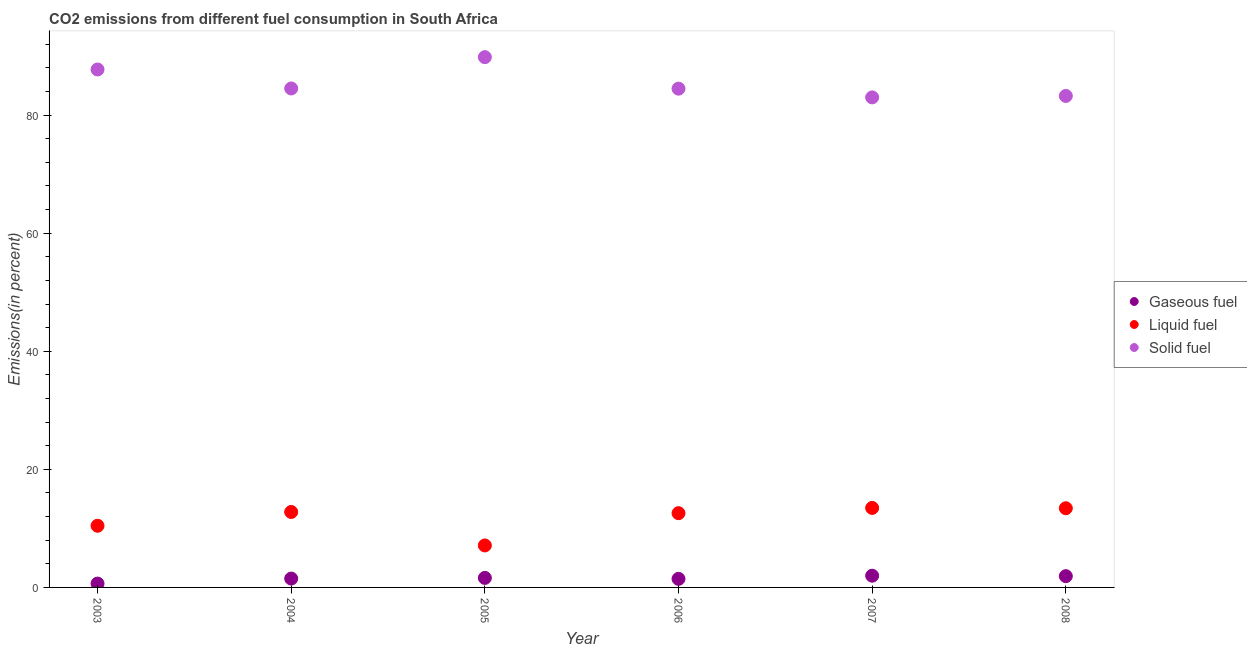Is the number of dotlines equal to the number of legend labels?
Your answer should be very brief. Yes. What is the percentage of solid fuel emission in 2007?
Your answer should be very brief. 83. Across all years, what is the maximum percentage of gaseous fuel emission?
Provide a short and direct response. 1.99. Across all years, what is the minimum percentage of solid fuel emission?
Make the answer very short. 83. In which year was the percentage of solid fuel emission maximum?
Provide a short and direct response. 2005. What is the total percentage of solid fuel emission in the graph?
Ensure brevity in your answer.  512.79. What is the difference between the percentage of solid fuel emission in 2005 and that in 2008?
Your answer should be very brief. 6.57. What is the difference between the percentage of gaseous fuel emission in 2003 and the percentage of liquid fuel emission in 2004?
Keep it short and to the point. -12.13. What is the average percentage of solid fuel emission per year?
Offer a terse response. 85.46. In the year 2008, what is the difference between the percentage of gaseous fuel emission and percentage of liquid fuel emission?
Provide a succinct answer. -11.5. What is the ratio of the percentage of gaseous fuel emission in 2003 to that in 2008?
Offer a terse response. 0.34. What is the difference between the highest and the second highest percentage of solid fuel emission?
Ensure brevity in your answer.  2.09. What is the difference between the highest and the lowest percentage of solid fuel emission?
Your response must be concise. 6.81. In how many years, is the percentage of gaseous fuel emission greater than the average percentage of gaseous fuel emission taken over all years?
Your answer should be compact. 3. Does the percentage of liquid fuel emission monotonically increase over the years?
Your answer should be compact. No. How many dotlines are there?
Give a very brief answer. 3. Are the values on the major ticks of Y-axis written in scientific E-notation?
Your response must be concise. No. Where does the legend appear in the graph?
Keep it short and to the point. Center right. How many legend labels are there?
Your response must be concise. 3. How are the legend labels stacked?
Your answer should be compact. Vertical. What is the title of the graph?
Provide a succinct answer. CO2 emissions from different fuel consumption in South Africa. Does "Nuclear sources" appear as one of the legend labels in the graph?
Keep it short and to the point. No. What is the label or title of the Y-axis?
Your answer should be very brief. Emissions(in percent). What is the Emissions(in percent) of Gaseous fuel in 2003?
Keep it short and to the point. 0.65. What is the Emissions(in percent) in Liquid fuel in 2003?
Offer a terse response. 10.45. What is the Emissions(in percent) in Solid fuel in 2003?
Your response must be concise. 87.73. What is the Emissions(in percent) of Gaseous fuel in 2004?
Ensure brevity in your answer.  1.5. What is the Emissions(in percent) of Liquid fuel in 2004?
Provide a succinct answer. 12.78. What is the Emissions(in percent) of Solid fuel in 2004?
Keep it short and to the point. 84.51. What is the Emissions(in percent) of Gaseous fuel in 2005?
Give a very brief answer. 1.61. What is the Emissions(in percent) in Liquid fuel in 2005?
Give a very brief answer. 7.11. What is the Emissions(in percent) in Solid fuel in 2005?
Your answer should be very brief. 89.82. What is the Emissions(in percent) of Gaseous fuel in 2006?
Your answer should be compact. 1.45. What is the Emissions(in percent) in Liquid fuel in 2006?
Give a very brief answer. 12.58. What is the Emissions(in percent) in Solid fuel in 2006?
Your answer should be very brief. 84.48. What is the Emissions(in percent) in Gaseous fuel in 2007?
Offer a very short reply. 1.99. What is the Emissions(in percent) of Liquid fuel in 2007?
Offer a very short reply. 13.47. What is the Emissions(in percent) in Solid fuel in 2007?
Provide a short and direct response. 83. What is the Emissions(in percent) of Gaseous fuel in 2008?
Make the answer very short. 1.91. What is the Emissions(in percent) of Liquid fuel in 2008?
Give a very brief answer. 13.41. What is the Emissions(in percent) in Solid fuel in 2008?
Give a very brief answer. 83.25. Across all years, what is the maximum Emissions(in percent) of Gaseous fuel?
Your answer should be compact. 1.99. Across all years, what is the maximum Emissions(in percent) of Liquid fuel?
Your answer should be very brief. 13.47. Across all years, what is the maximum Emissions(in percent) of Solid fuel?
Give a very brief answer. 89.82. Across all years, what is the minimum Emissions(in percent) of Gaseous fuel?
Give a very brief answer. 0.65. Across all years, what is the minimum Emissions(in percent) of Liquid fuel?
Give a very brief answer. 7.11. Across all years, what is the minimum Emissions(in percent) of Solid fuel?
Ensure brevity in your answer.  83. What is the total Emissions(in percent) of Gaseous fuel in the graph?
Your response must be concise. 9.11. What is the total Emissions(in percent) in Liquid fuel in the graph?
Provide a succinct answer. 69.79. What is the total Emissions(in percent) in Solid fuel in the graph?
Your response must be concise. 512.79. What is the difference between the Emissions(in percent) in Gaseous fuel in 2003 and that in 2004?
Make the answer very short. -0.85. What is the difference between the Emissions(in percent) in Liquid fuel in 2003 and that in 2004?
Provide a succinct answer. -2.33. What is the difference between the Emissions(in percent) of Solid fuel in 2003 and that in 2004?
Ensure brevity in your answer.  3.22. What is the difference between the Emissions(in percent) of Gaseous fuel in 2003 and that in 2005?
Offer a very short reply. -0.96. What is the difference between the Emissions(in percent) in Liquid fuel in 2003 and that in 2005?
Give a very brief answer. 3.34. What is the difference between the Emissions(in percent) in Solid fuel in 2003 and that in 2005?
Provide a short and direct response. -2.09. What is the difference between the Emissions(in percent) in Gaseous fuel in 2003 and that in 2006?
Offer a terse response. -0.8. What is the difference between the Emissions(in percent) of Liquid fuel in 2003 and that in 2006?
Your answer should be compact. -2.13. What is the difference between the Emissions(in percent) of Solid fuel in 2003 and that in 2006?
Provide a succinct answer. 3.25. What is the difference between the Emissions(in percent) of Gaseous fuel in 2003 and that in 2007?
Provide a succinct answer. -1.34. What is the difference between the Emissions(in percent) of Liquid fuel in 2003 and that in 2007?
Ensure brevity in your answer.  -3.02. What is the difference between the Emissions(in percent) in Solid fuel in 2003 and that in 2007?
Ensure brevity in your answer.  4.73. What is the difference between the Emissions(in percent) of Gaseous fuel in 2003 and that in 2008?
Make the answer very short. -1.26. What is the difference between the Emissions(in percent) in Liquid fuel in 2003 and that in 2008?
Your response must be concise. -2.97. What is the difference between the Emissions(in percent) of Solid fuel in 2003 and that in 2008?
Ensure brevity in your answer.  4.48. What is the difference between the Emissions(in percent) of Gaseous fuel in 2004 and that in 2005?
Ensure brevity in your answer.  -0.11. What is the difference between the Emissions(in percent) in Liquid fuel in 2004 and that in 2005?
Keep it short and to the point. 5.67. What is the difference between the Emissions(in percent) in Solid fuel in 2004 and that in 2005?
Ensure brevity in your answer.  -5.3. What is the difference between the Emissions(in percent) of Gaseous fuel in 2004 and that in 2006?
Give a very brief answer. 0.05. What is the difference between the Emissions(in percent) of Liquid fuel in 2004 and that in 2006?
Make the answer very short. 0.2. What is the difference between the Emissions(in percent) in Solid fuel in 2004 and that in 2006?
Your answer should be compact. 0.03. What is the difference between the Emissions(in percent) in Gaseous fuel in 2004 and that in 2007?
Your response must be concise. -0.49. What is the difference between the Emissions(in percent) in Liquid fuel in 2004 and that in 2007?
Make the answer very short. -0.69. What is the difference between the Emissions(in percent) in Solid fuel in 2004 and that in 2007?
Your answer should be compact. 1.51. What is the difference between the Emissions(in percent) in Gaseous fuel in 2004 and that in 2008?
Make the answer very short. -0.41. What is the difference between the Emissions(in percent) in Liquid fuel in 2004 and that in 2008?
Your answer should be very brief. -0.63. What is the difference between the Emissions(in percent) of Solid fuel in 2004 and that in 2008?
Your response must be concise. 1.27. What is the difference between the Emissions(in percent) of Gaseous fuel in 2005 and that in 2006?
Make the answer very short. 0.16. What is the difference between the Emissions(in percent) of Liquid fuel in 2005 and that in 2006?
Provide a succinct answer. -5.47. What is the difference between the Emissions(in percent) in Solid fuel in 2005 and that in 2006?
Offer a very short reply. 5.34. What is the difference between the Emissions(in percent) in Gaseous fuel in 2005 and that in 2007?
Provide a succinct answer. -0.37. What is the difference between the Emissions(in percent) in Liquid fuel in 2005 and that in 2007?
Keep it short and to the point. -6.36. What is the difference between the Emissions(in percent) of Solid fuel in 2005 and that in 2007?
Provide a short and direct response. 6.82. What is the difference between the Emissions(in percent) in Gaseous fuel in 2005 and that in 2008?
Make the answer very short. -0.3. What is the difference between the Emissions(in percent) of Liquid fuel in 2005 and that in 2008?
Provide a short and direct response. -6.3. What is the difference between the Emissions(in percent) of Solid fuel in 2005 and that in 2008?
Make the answer very short. 6.57. What is the difference between the Emissions(in percent) in Gaseous fuel in 2006 and that in 2007?
Your answer should be very brief. -0.54. What is the difference between the Emissions(in percent) in Liquid fuel in 2006 and that in 2007?
Your answer should be very brief. -0.89. What is the difference between the Emissions(in percent) of Solid fuel in 2006 and that in 2007?
Ensure brevity in your answer.  1.48. What is the difference between the Emissions(in percent) in Gaseous fuel in 2006 and that in 2008?
Offer a very short reply. -0.46. What is the difference between the Emissions(in percent) in Liquid fuel in 2006 and that in 2008?
Make the answer very short. -0.83. What is the difference between the Emissions(in percent) in Solid fuel in 2006 and that in 2008?
Offer a very short reply. 1.23. What is the difference between the Emissions(in percent) in Gaseous fuel in 2007 and that in 2008?
Make the answer very short. 0.08. What is the difference between the Emissions(in percent) in Liquid fuel in 2007 and that in 2008?
Your answer should be compact. 0.05. What is the difference between the Emissions(in percent) of Solid fuel in 2007 and that in 2008?
Give a very brief answer. -0.25. What is the difference between the Emissions(in percent) in Gaseous fuel in 2003 and the Emissions(in percent) in Liquid fuel in 2004?
Your answer should be very brief. -12.13. What is the difference between the Emissions(in percent) in Gaseous fuel in 2003 and the Emissions(in percent) in Solid fuel in 2004?
Keep it short and to the point. -83.86. What is the difference between the Emissions(in percent) of Liquid fuel in 2003 and the Emissions(in percent) of Solid fuel in 2004?
Offer a terse response. -74.07. What is the difference between the Emissions(in percent) in Gaseous fuel in 2003 and the Emissions(in percent) in Liquid fuel in 2005?
Provide a short and direct response. -6.46. What is the difference between the Emissions(in percent) of Gaseous fuel in 2003 and the Emissions(in percent) of Solid fuel in 2005?
Your response must be concise. -89.17. What is the difference between the Emissions(in percent) of Liquid fuel in 2003 and the Emissions(in percent) of Solid fuel in 2005?
Your answer should be very brief. -79.37. What is the difference between the Emissions(in percent) of Gaseous fuel in 2003 and the Emissions(in percent) of Liquid fuel in 2006?
Provide a succinct answer. -11.93. What is the difference between the Emissions(in percent) of Gaseous fuel in 2003 and the Emissions(in percent) of Solid fuel in 2006?
Offer a terse response. -83.83. What is the difference between the Emissions(in percent) of Liquid fuel in 2003 and the Emissions(in percent) of Solid fuel in 2006?
Make the answer very short. -74.03. What is the difference between the Emissions(in percent) in Gaseous fuel in 2003 and the Emissions(in percent) in Liquid fuel in 2007?
Keep it short and to the point. -12.82. What is the difference between the Emissions(in percent) of Gaseous fuel in 2003 and the Emissions(in percent) of Solid fuel in 2007?
Your answer should be compact. -82.35. What is the difference between the Emissions(in percent) of Liquid fuel in 2003 and the Emissions(in percent) of Solid fuel in 2007?
Give a very brief answer. -72.56. What is the difference between the Emissions(in percent) in Gaseous fuel in 2003 and the Emissions(in percent) in Liquid fuel in 2008?
Provide a short and direct response. -12.76. What is the difference between the Emissions(in percent) in Gaseous fuel in 2003 and the Emissions(in percent) in Solid fuel in 2008?
Offer a terse response. -82.6. What is the difference between the Emissions(in percent) in Liquid fuel in 2003 and the Emissions(in percent) in Solid fuel in 2008?
Provide a short and direct response. -72.8. What is the difference between the Emissions(in percent) in Gaseous fuel in 2004 and the Emissions(in percent) in Liquid fuel in 2005?
Offer a very short reply. -5.61. What is the difference between the Emissions(in percent) in Gaseous fuel in 2004 and the Emissions(in percent) in Solid fuel in 2005?
Provide a succinct answer. -88.32. What is the difference between the Emissions(in percent) of Liquid fuel in 2004 and the Emissions(in percent) of Solid fuel in 2005?
Your answer should be compact. -77.04. What is the difference between the Emissions(in percent) in Gaseous fuel in 2004 and the Emissions(in percent) in Liquid fuel in 2006?
Ensure brevity in your answer.  -11.08. What is the difference between the Emissions(in percent) in Gaseous fuel in 2004 and the Emissions(in percent) in Solid fuel in 2006?
Your response must be concise. -82.98. What is the difference between the Emissions(in percent) of Liquid fuel in 2004 and the Emissions(in percent) of Solid fuel in 2006?
Ensure brevity in your answer.  -71.7. What is the difference between the Emissions(in percent) of Gaseous fuel in 2004 and the Emissions(in percent) of Liquid fuel in 2007?
Your response must be concise. -11.97. What is the difference between the Emissions(in percent) in Gaseous fuel in 2004 and the Emissions(in percent) in Solid fuel in 2007?
Your answer should be compact. -81.5. What is the difference between the Emissions(in percent) in Liquid fuel in 2004 and the Emissions(in percent) in Solid fuel in 2007?
Make the answer very short. -70.22. What is the difference between the Emissions(in percent) of Gaseous fuel in 2004 and the Emissions(in percent) of Liquid fuel in 2008?
Keep it short and to the point. -11.91. What is the difference between the Emissions(in percent) of Gaseous fuel in 2004 and the Emissions(in percent) of Solid fuel in 2008?
Make the answer very short. -81.75. What is the difference between the Emissions(in percent) of Liquid fuel in 2004 and the Emissions(in percent) of Solid fuel in 2008?
Give a very brief answer. -70.47. What is the difference between the Emissions(in percent) of Gaseous fuel in 2005 and the Emissions(in percent) of Liquid fuel in 2006?
Give a very brief answer. -10.96. What is the difference between the Emissions(in percent) in Gaseous fuel in 2005 and the Emissions(in percent) in Solid fuel in 2006?
Your answer should be very brief. -82.87. What is the difference between the Emissions(in percent) of Liquid fuel in 2005 and the Emissions(in percent) of Solid fuel in 2006?
Offer a very short reply. -77.37. What is the difference between the Emissions(in percent) in Gaseous fuel in 2005 and the Emissions(in percent) in Liquid fuel in 2007?
Your answer should be very brief. -11.85. What is the difference between the Emissions(in percent) in Gaseous fuel in 2005 and the Emissions(in percent) in Solid fuel in 2007?
Make the answer very short. -81.39. What is the difference between the Emissions(in percent) of Liquid fuel in 2005 and the Emissions(in percent) of Solid fuel in 2007?
Your answer should be very brief. -75.89. What is the difference between the Emissions(in percent) in Gaseous fuel in 2005 and the Emissions(in percent) in Liquid fuel in 2008?
Offer a terse response. -11.8. What is the difference between the Emissions(in percent) in Gaseous fuel in 2005 and the Emissions(in percent) in Solid fuel in 2008?
Keep it short and to the point. -81.64. What is the difference between the Emissions(in percent) of Liquid fuel in 2005 and the Emissions(in percent) of Solid fuel in 2008?
Provide a short and direct response. -76.14. What is the difference between the Emissions(in percent) of Gaseous fuel in 2006 and the Emissions(in percent) of Liquid fuel in 2007?
Provide a short and direct response. -12.02. What is the difference between the Emissions(in percent) in Gaseous fuel in 2006 and the Emissions(in percent) in Solid fuel in 2007?
Your answer should be very brief. -81.55. What is the difference between the Emissions(in percent) in Liquid fuel in 2006 and the Emissions(in percent) in Solid fuel in 2007?
Keep it short and to the point. -70.43. What is the difference between the Emissions(in percent) of Gaseous fuel in 2006 and the Emissions(in percent) of Liquid fuel in 2008?
Give a very brief answer. -11.96. What is the difference between the Emissions(in percent) in Gaseous fuel in 2006 and the Emissions(in percent) in Solid fuel in 2008?
Offer a terse response. -81.8. What is the difference between the Emissions(in percent) of Liquid fuel in 2006 and the Emissions(in percent) of Solid fuel in 2008?
Make the answer very short. -70.67. What is the difference between the Emissions(in percent) of Gaseous fuel in 2007 and the Emissions(in percent) of Liquid fuel in 2008?
Provide a succinct answer. -11.43. What is the difference between the Emissions(in percent) of Gaseous fuel in 2007 and the Emissions(in percent) of Solid fuel in 2008?
Ensure brevity in your answer.  -81.26. What is the difference between the Emissions(in percent) of Liquid fuel in 2007 and the Emissions(in percent) of Solid fuel in 2008?
Offer a terse response. -69.78. What is the average Emissions(in percent) in Gaseous fuel per year?
Provide a succinct answer. 1.52. What is the average Emissions(in percent) in Liquid fuel per year?
Your response must be concise. 11.63. What is the average Emissions(in percent) of Solid fuel per year?
Ensure brevity in your answer.  85.46. In the year 2003, what is the difference between the Emissions(in percent) of Gaseous fuel and Emissions(in percent) of Liquid fuel?
Make the answer very short. -9.8. In the year 2003, what is the difference between the Emissions(in percent) of Gaseous fuel and Emissions(in percent) of Solid fuel?
Make the answer very short. -87.08. In the year 2003, what is the difference between the Emissions(in percent) of Liquid fuel and Emissions(in percent) of Solid fuel?
Give a very brief answer. -77.29. In the year 2004, what is the difference between the Emissions(in percent) of Gaseous fuel and Emissions(in percent) of Liquid fuel?
Your response must be concise. -11.28. In the year 2004, what is the difference between the Emissions(in percent) of Gaseous fuel and Emissions(in percent) of Solid fuel?
Your response must be concise. -83.01. In the year 2004, what is the difference between the Emissions(in percent) of Liquid fuel and Emissions(in percent) of Solid fuel?
Provide a short and direct response. -71.73. In the year 2005, what is the difference between the Emissions(in percent) in Gaseous fuel and Emissions(in percent) in Liquid fuel?
Keep it short and to the point. -5.5. In the year 2005, what is the difference between the Emissions(in percent) in Gaseous fuel and Emissions(in percent) in Solid fuel?
Your response must be concise. -88.2. In the year 2005, what is the difference between the Emissions(in percent) of Liquid fuel and Emissions(in percent) of Solid fuel?
Keep it short and to the point. -82.71. In the year 2006, what is the difference between the Emissions(in percent) of Gaseous fuel and Emissions(in percent) of Liquid fuel?
Provide a succinct answer. -11.13. In the year 2006, what is the difference between the Emissions(in percent) of Gaseous fuel and Emissions(in percent) of Solid fuel?
Make the answer very short. -83.03. In the year 2006, what is the difference between the Emissions(in percent) in Liquid fuel and Emissions(in percent) in Solid fuel?
Provide a short and direct response. -71.9. In the year 2007, what is the difference between the Emissions(in percent) of Gaseous fuel and Emissions(in percent) of Liquid fuel?
Keep it short and to the point. -11.48. In the year 2007, what is the difference between the Emissions(in percent) in Gaseous fuel and Emissions(in percent) in Solid fuel?
Make the answer very short. -81.02. In the year 2007, what is the difference between the Emissions(in percent) of Liquid fuel and Emissions(in percent) of Solid fuel?
Offer a very short reply. -69.54. In the year 2008, what is the difference between the Emissions(in percent) in Gaseous fuel and Emissions(in percent) in Liquid fuel?
Make the answer very short. -11.5. In the year 2008, what is the difference between the Emissions(in percent) in Gaseous fuel and Emissions(in percent) in Solid fuel?
Give a very brief answer. -81.34. In the year 2008, what is the difference between the Emissions(in percent) of Liquid fuel and Emissions(in percent) of Solid fuel?
Your response must be concise. -69.84. What is the ratio of the Emissions(in percent) of Gaseous fuel in 2003 to that in 2004?
Your response must be concise. 0.43. What is the ratio of the Emissions(in percent) of Liquid fuel in 2003 to that in 2004?
Offer a terse response. 0.82. What is the ratio of the Emissions(in percent) in Solid fuel in 2003 to that in 2004?
Your answer should be very brief. 1.04. What is the ratio of the Emissions(in percent) in Gaseous fuel in 2003 to that in 2005?
Offer a terse response. 0.4. What is the ratio of the Emissions(in percent) in Liquid fuel in 2003 to that in 2005?
Your response must be concise. 1.47. What is the ratio of the Emissions(in percent) of Solid fuel in 2003 to that in 2005?
Your answer should be compact. 0.98. What is the ratio of the Emissions(in percent) of Gaseous fuel in 2003 to that in 2006?
Give a very brief answer. 0.45. What is the ratio of the Emissions(in percent) of Liquid fuel in 2003 to that in 2006?
Your response must be concise. 0.83. What is the ratio of the Emissions(in percent) in Solid fuel in 2003 to that in 2006?
Your answer should be very brief. 1.04. What is the ratio of the Emissions(in percent) in Gaseous fuel in 2003 to that in 2007?
Provide a short and direct response. 0.33. What is the ratio of the Emissions(in percent) of Liquid fuel in 2003 to that in 2007?
Your answer should be very brief. 0.78. What is the ratio of the Emissions(in percent) in Solid fuel in 2003 to that in 2007?
Offer a very short reply. 1.06. What is the ratio of the Emissions(in percent) in Gaseous fuel in 2003 to that in 2008?
Give a very brief answer. 0.34. What is the ratio of the Emissions(in percent) of Liquid fuel in 2003 to that in 2008?
Your response must be concise. 0.78. What is the ratio of the Emissions(in percent) in Solid fuel in 2003 to that in 2008?
Give a very brief answer. 1.05. What is the ratio of the Emissions(in percent) of Gaseous fuel in 2004 to that in 2005?
Your response must be concise. 0.93. What is the ratio of the Emissions(in percent) in Liquid fuel in 2004 to that in 2005?
Ensure brevity in your answer.  1.8. What is the ratio of the Emissions(in percent) of Solid fuel in 2004 to that in 2005?
Your answer should be very brief. 0.94. What is the ratio of the Emissions(in percent) in Gaseous fuel in 2004 to that in 2006?
Keep it short and to the point. 1.03. What is the ratio of the Emissions(in percent) of Liquid fuel in 2004 to that in 2006?
Give a very brief answer. 1.02. What is the ratio of the Emissions(in percent) of Solid fuel in 2004 to that in 2006?
Provide a succinct answer. 1. What is the ratio of the Emissions(in percent) of Gaseous fuel in 2004 to that in 2007?
Your answer should be compact. 0.75. What is the ratio of the Emissions(in percent) of Liquid fuel in 2004 to that in 2007?
Keep it short and to the point. 0.95. What is the ratio of the Emissions(in percent) in Solid fuel in 2004 to that in 2007?
Provide a succinct answer. 1.02. What is the ratio of the Emissions(in percent) of Gaseous fuel in 2004 to that in 2008?
Ensure brevity in your answer.  0.79. What is the ratio of the Emissions(in percent) of Liquid fuel in 2004 to that in 2008?
Ensure brevity in your answer.  0.95. What is the ratio of the Emissions(in percent) of Solid fuel in 2004 to that in 2008?
Your response must be concise. 1.02. What is the ratio of the Emissions(in percent) of Liquid fuel in 2005 to that in 2006?
Keep it short and to the point. 0.57. What is the ratio of the Emissions(in percent) in Solid fuel in 2005 to that in 2006?
Provide a succinct answer. 1.06. What is the ratio of the Emissions(in percent) in Gaseous fuel in 2005 to that in 2007?
Ensure brevity in your answer.  0.81. What is the ratio of the Emissions(in percent) in Liquid fuel in 2005 to that in 2007?
Ensure brevity in your answer.  0.53. What is the ratio of the Emissions(in percent) in Solid fuel in 2005 to that in 2007?
Your answer should be compact. 1.08. What is the ratio of the Emissions(in percent) in Gaseous fuel in 2005 to that in 2008?
Your response must be concise. 0.85. What is the ratio of the Emissions(in percent) in Liquid fuel in 2005 to that in 2008?
Your answer should be very brief. 0.53. What is the ratio of the Emissions(in percent) in Solid fuel in 2005 to that in 2008?
Ensure brevity in your answer.  1.08. What is the ratio of the Emissions(in percent) in Gaseous fuel in 2006 to that in 2007?
Your response must be concise. 0.73. What is the ratio of the Emissions(in percent) in Liquid fuel in 2006 to that in 2007?
Provide a succinct answer. 0.93. What is the ratio of the Emissions(in percent) of Solid fuel in 2006 to that in 2007?
Provide a short and direct response. 1.02. What is the ratio of the Emissions(in percent) of Gaseous fuel in 2006 to that in 2008?
Ensure brevity in your answer.  0.76. What is the ratio of the Emissions(in percent) of Liquid fuel in 2006 to that in 2008?
Make the answer very short. 0.94. What is the ratio of the Emissions(in percent) of Solid fuel in 2006 to that in 2008?
Provide a short and direct response. 1.01. What is the ratio of the Emissions(in percent) of Gaseous fuel in 2007 to that in 2008?
Your answer should be very brief. 1.04. What is the difference between the highest and the second highest Emissions(in percent) of Gaseous fuel?
Offer a very short reply. 0.08. What is the difference between the highest and the second highest Emissions(in percent) of Liquid fuel?
Provide a short and direct response. 0.05. What is the difference between the highest and the second highest Emissions(in percent) of Solid fuel?
Your answer should be very brief. 2.09. What is the difference between the highest and the lowest Emissions(in percent) of Gaseous fuel?
Offer a terse response. 1.34. What is the difference between the highest and the lowest Emissions(in percent) of Liquid fuel?
Offer a terse response. 6.36. What is the difference between the highest and the lowest Emissions(in percent) in Solid fuel?
Provide a short and direct response. 6.82. 